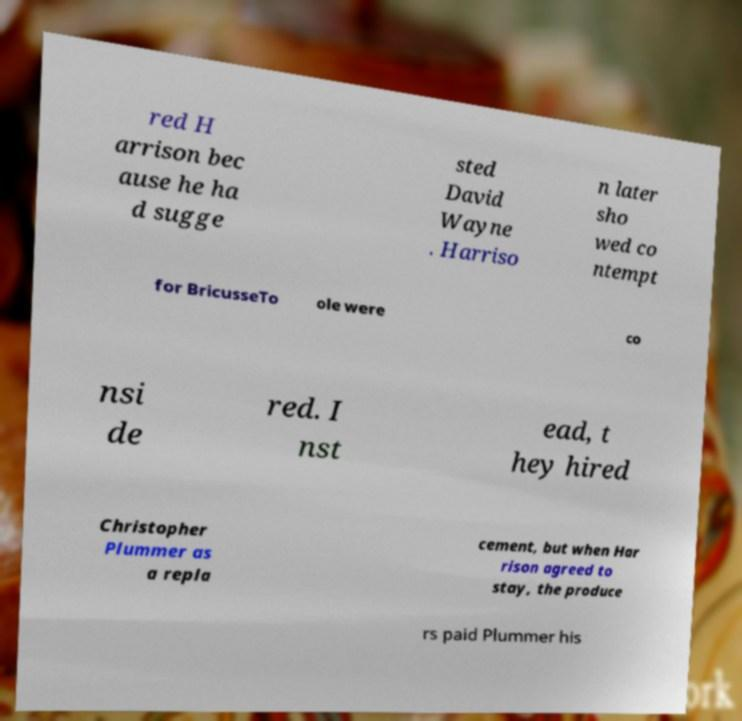Please read and relay the text visible in this image. What does it say? red H arrison bec ause he ha d sugge sted David Wayne . Harriso n later sho wed co ntempt for BricusseTo ole were co nsi de red. I nst ead, t hey hired Christopher Plummer as a repla cement, but when Har rison agreed to stay, the produce rs paid Plummer his 